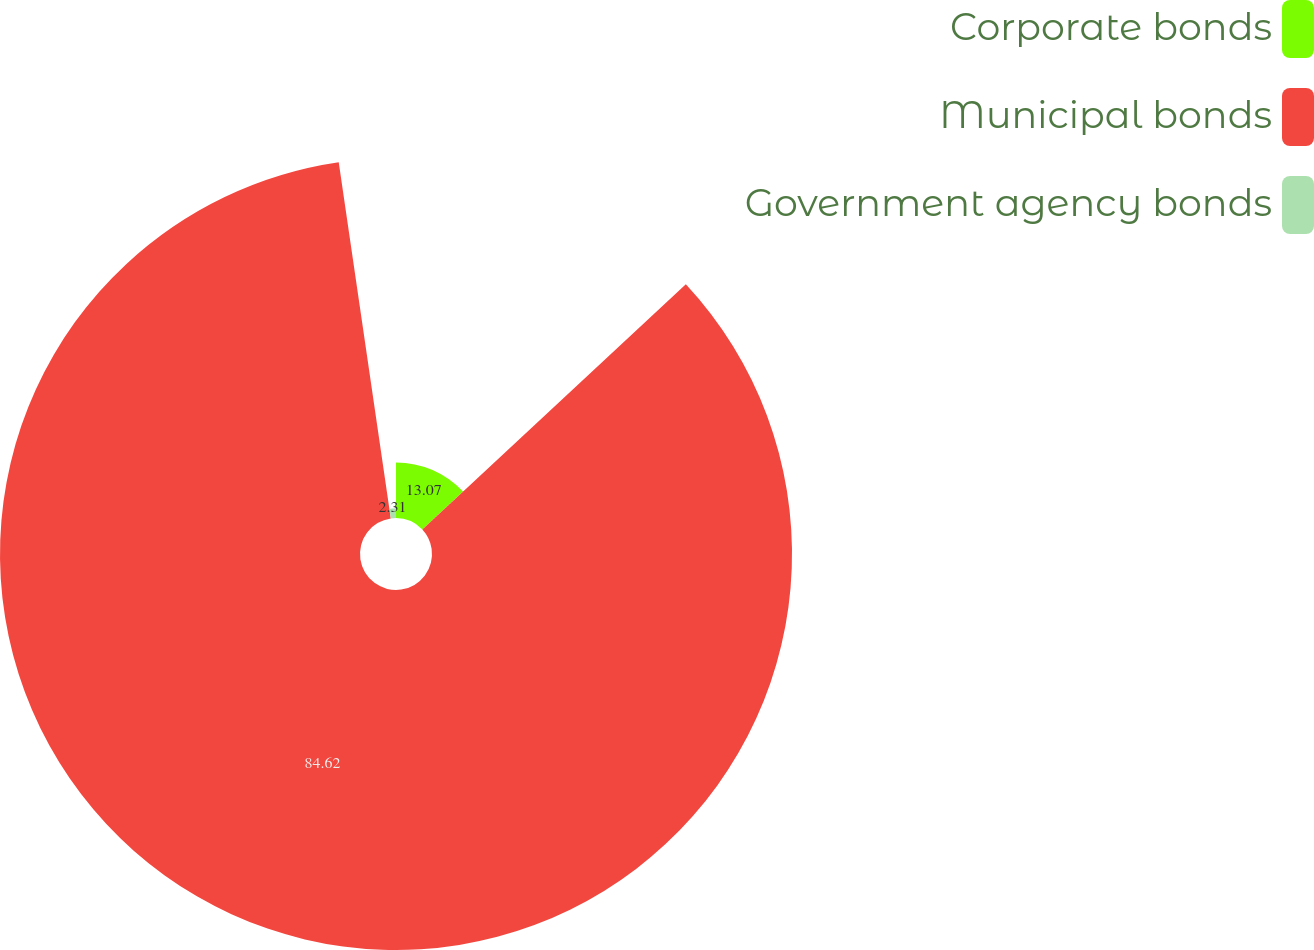<chart> <loc_0><loc_0><loc_500><loc_500><pie_chart><fcel>Corporate bonds<fcel>Municipal bonds<fcel>Government agency bonds<nl><fcel>13.07%<fcel>84.62%<fcel>2.31%<nl></chart> 